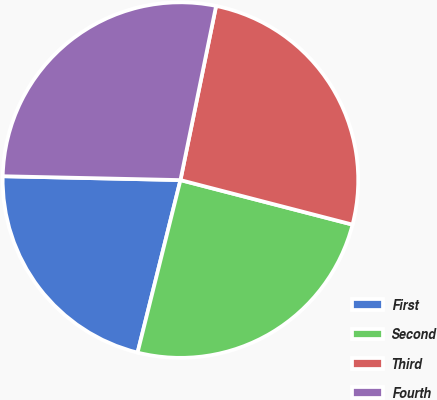Convert chart to OTSL. <chart><loc_0><loc_0><loc_500><loc_500><pie_chart><fcel>First<fcel>Second<fcel>Third<fcel>Fourth<nl><fcel>21.47%<fcel>24.85%<fcel>25.82%<fcel>27.87%<nl></chart> 